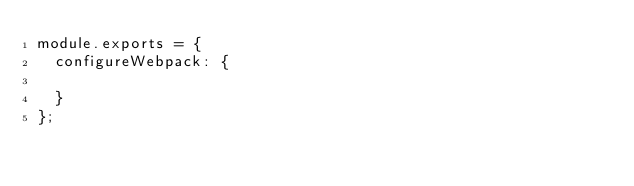<code> <loc_0><loc_0><loc_500><loc_500><_JavaScript_>module.exports = {
	configureWebpack: {

	}
};</code> 